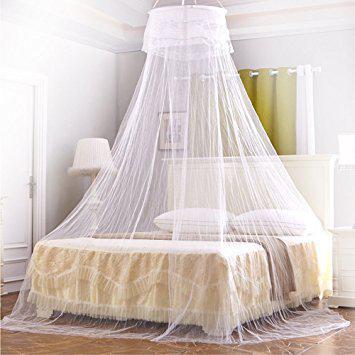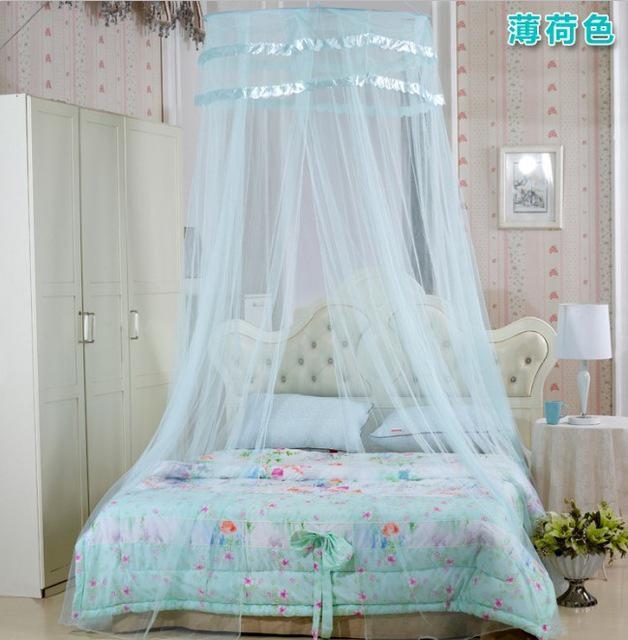The first image is the image on the left, the second image is the image on the right. Considering the images on both sides, is "Exactly one net is white." valid? Answer yes or no. Yes. The first image is the image on the left, the second image is the image on the right. For the images shown, is this caption "None of these bed canopies are presently covering a regular, rectangular bed." true? Answer yes or no. No. 